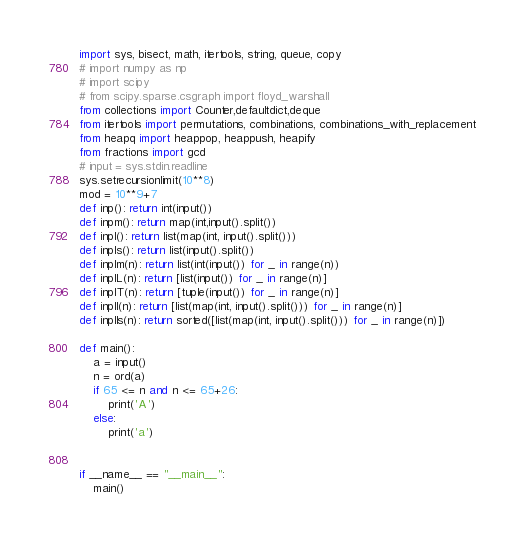<code> <loc_0><loc_0><loc_500><loc_500><_Python_>import sys, bisect, math, itertools, string, queue, copy
# import numpy as np
# import scipy
# from scipy.sparse.csgraph import floyd_warshall
from collections import Counter,defaultdict,deque
from itertools import permutations, combinations, combinations_with_replacement
from heapq import heappop, heappush, heapify
from fractions import gcd
# input = sys.stdin.readline
sys.setrecursionlimit(10**8)
mod = 10**9+7
def inp(): return int(input())
def inpm(): return map(int,input().split())
def inpl(): return list(map(int, input().split()))
def inpls(): return list(input().split())
def inplm(n): return list(int(input()) for _ in range(n))
def inplL(n): return [list(input()) for _ in range(n)]
def inplT(n): return [tuple(input()) for _ in range(n)]
def inpll(n): return [list(map(int, input().split())) for _ in range(n)]
def inplls(n): return sorted([list(map(int, input().split())) for _ in range(n)])

def main():
    a = input()
    n = ord(a)
    if 65 <= n and n <= 65+26:
        print('A')
    else:
        print('a')

    
if __name__ == "__main__":
    main()</code> 